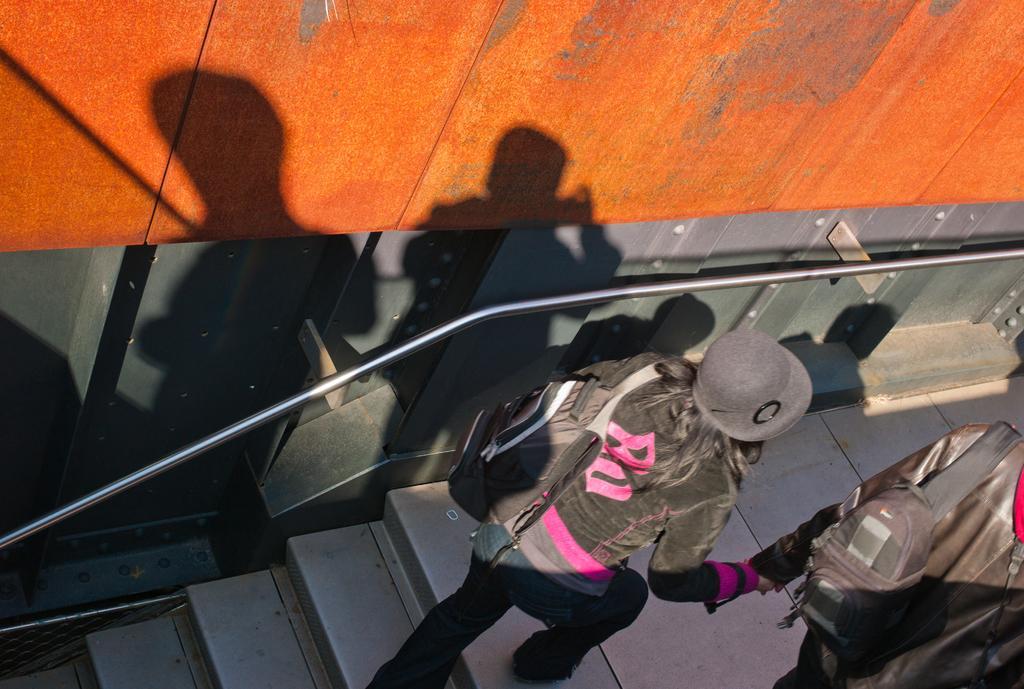How would you summarize this image in a sentence or two? There are two people walking and carrying bags and we can see steps and rod. We can see shadows of people on the wall. 